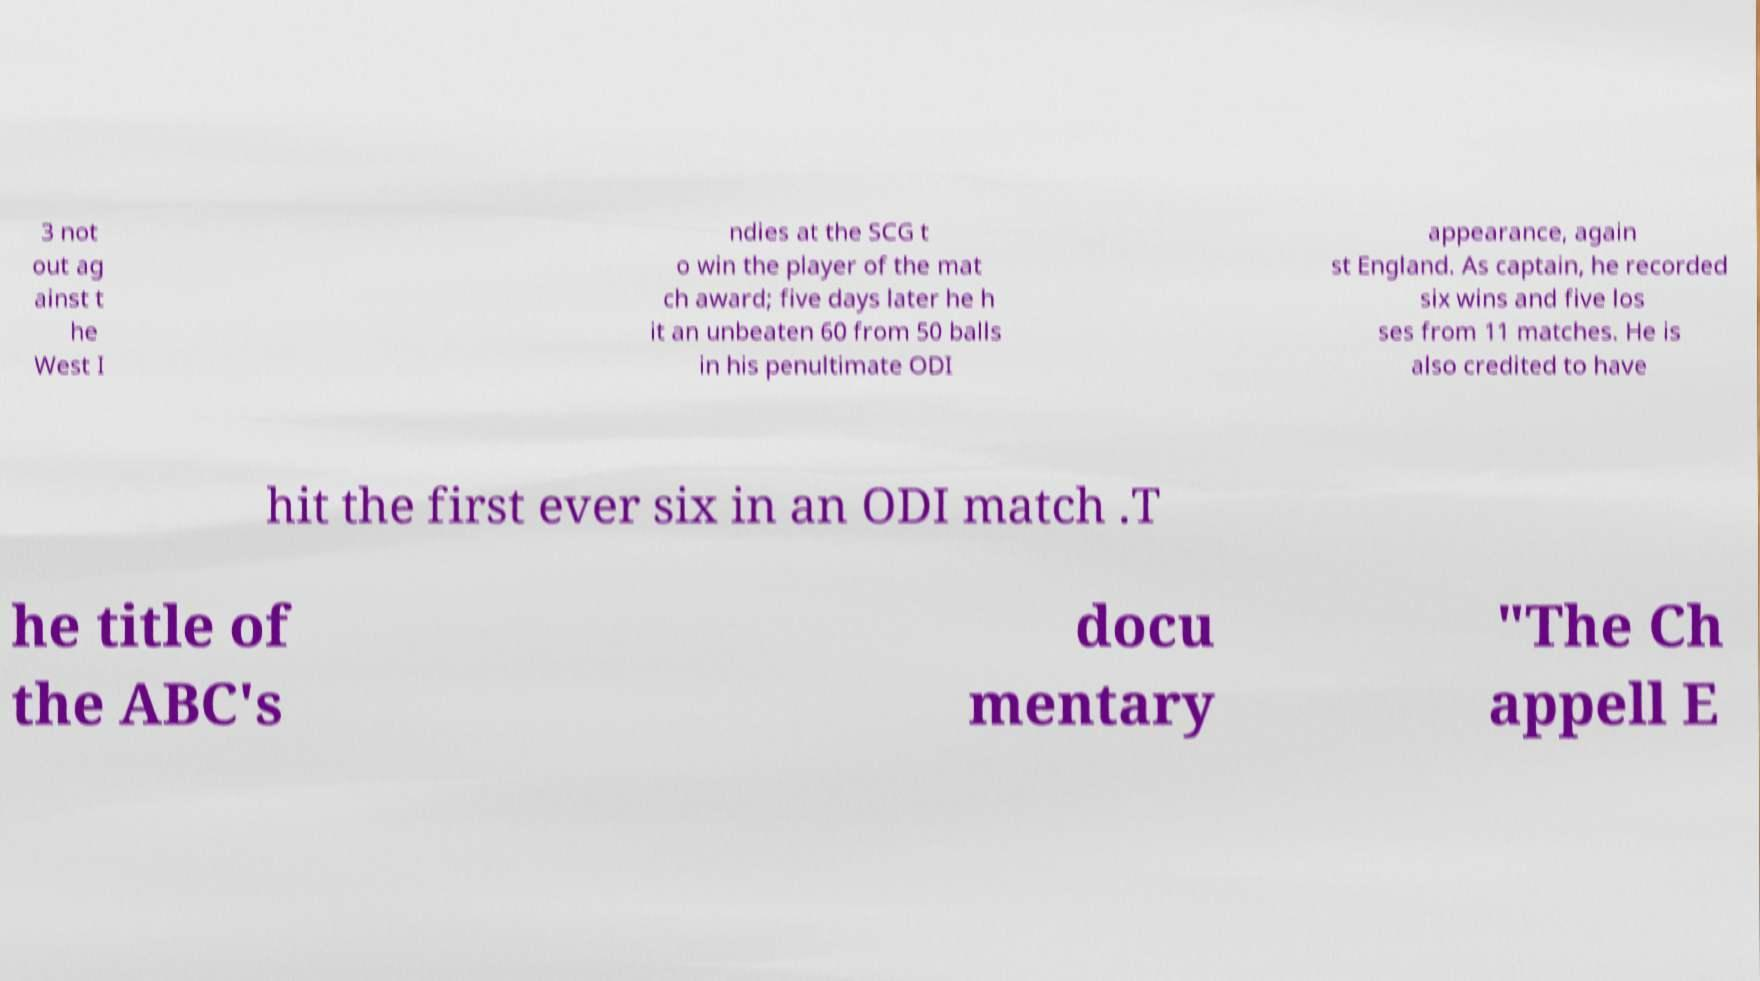Could you assist in decoding the text presented in this image and type it out clearly? 3 not out ag ainst t he West I ndies at the SCG t o win the player of the mat ch award; five days later he h it an unbeaten 60 from 50 balls in his penultimate ODI appearance, again st England. As captain, he recorded six wins and five los ses from 11 matches. He is also credited to have hit the first ever six in an ODI match .T he title of the ABC's docu mentary "The Ch appell E 